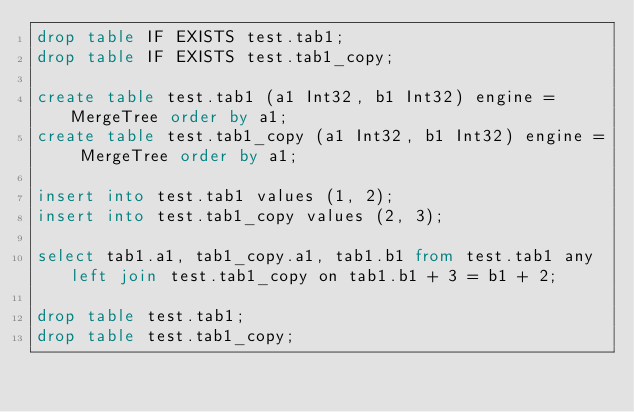Convert code to text. <code><loc_0><loc_0><loc_500><loc_500><_SQL_>drop table IF EXISTS test.tab1;
drop table IF EXISTS test.tab1_copy;

create table test.tab1 (a1 Int32, b1 Int32) engine = MergeTree order by a1;
create table test.tab1_copy (a1 Int32, b1 Int32) engine = MergeTree order by a1;

insert into test.tab1 values (1, 2);
insert into test.tab1_copy values (2, 3);

select tab1.a1, tab1_copy.a1, tab1.b1 from test.tab1 any left join test.tab1_copy on tab1.b1 + 3 = b1 + 2;

drop table test.tab1;
drop table test.tab1_copy;
</code> 